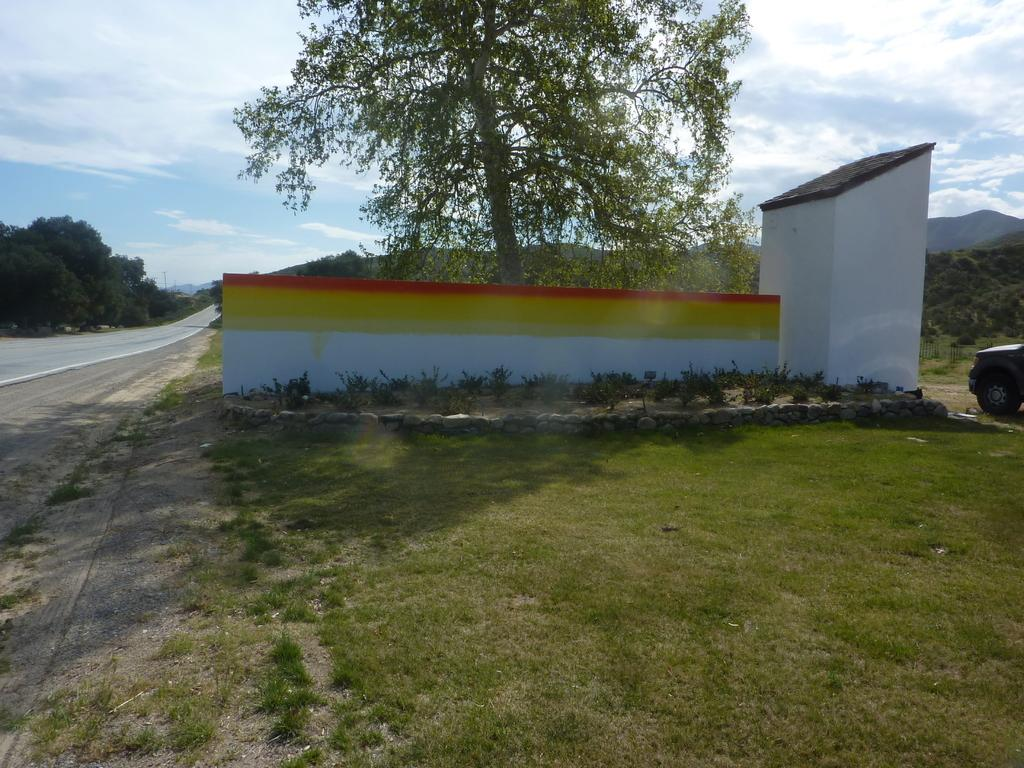What type of structure can be seen in the image? There is a shed in the image. What natural elements are present in the image? There are trees and the sky with clouds visible in the image. What man-made feature can be seen in the image? There is a road in the image. What mode of transportation is present in the image? A motor vehicle is present in the image. What type of vegetation is visible in the image? Shrubs are visible in the image. What type of material is present in the image? Stones are present in the image. What is the surface on which the shed and other objects are placed? The ground is visible in the image. How many lawyers are sitting at the table in the image? There is no table or lawyer present in the image. What type of sorting activity is taking place in the image? There is no sorting activity present in the image. 